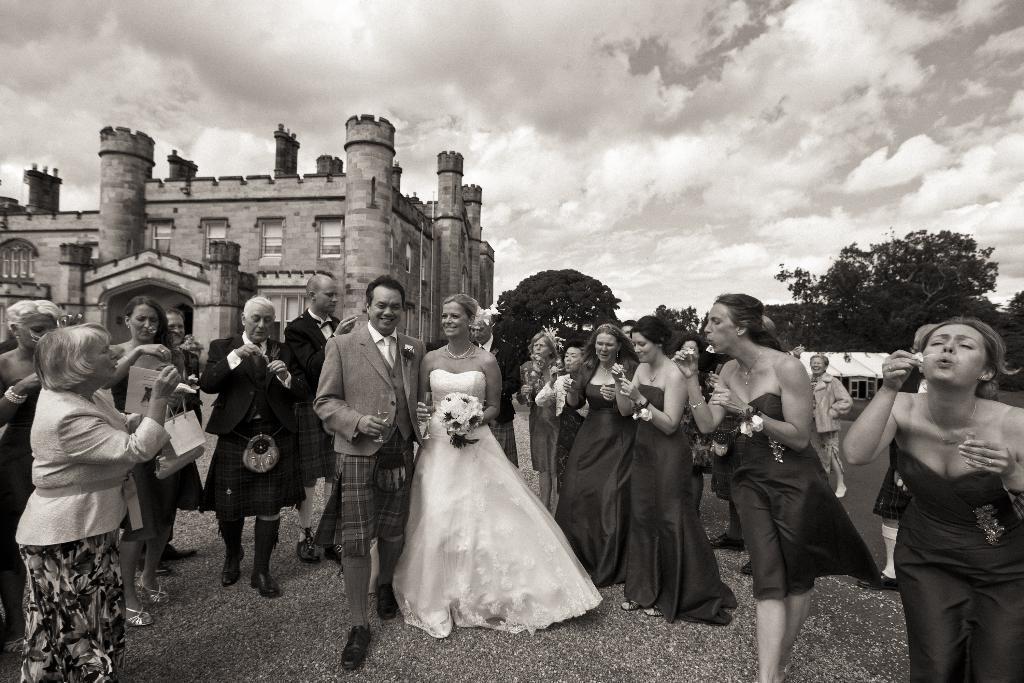Please provide a concise description of this image. This is a black and white picture, in the front there are many people standing, in the middle the couple seems to be newly married, in the back there is a castle, on the right side there are trees beside the castle and above its sky with clouds. 